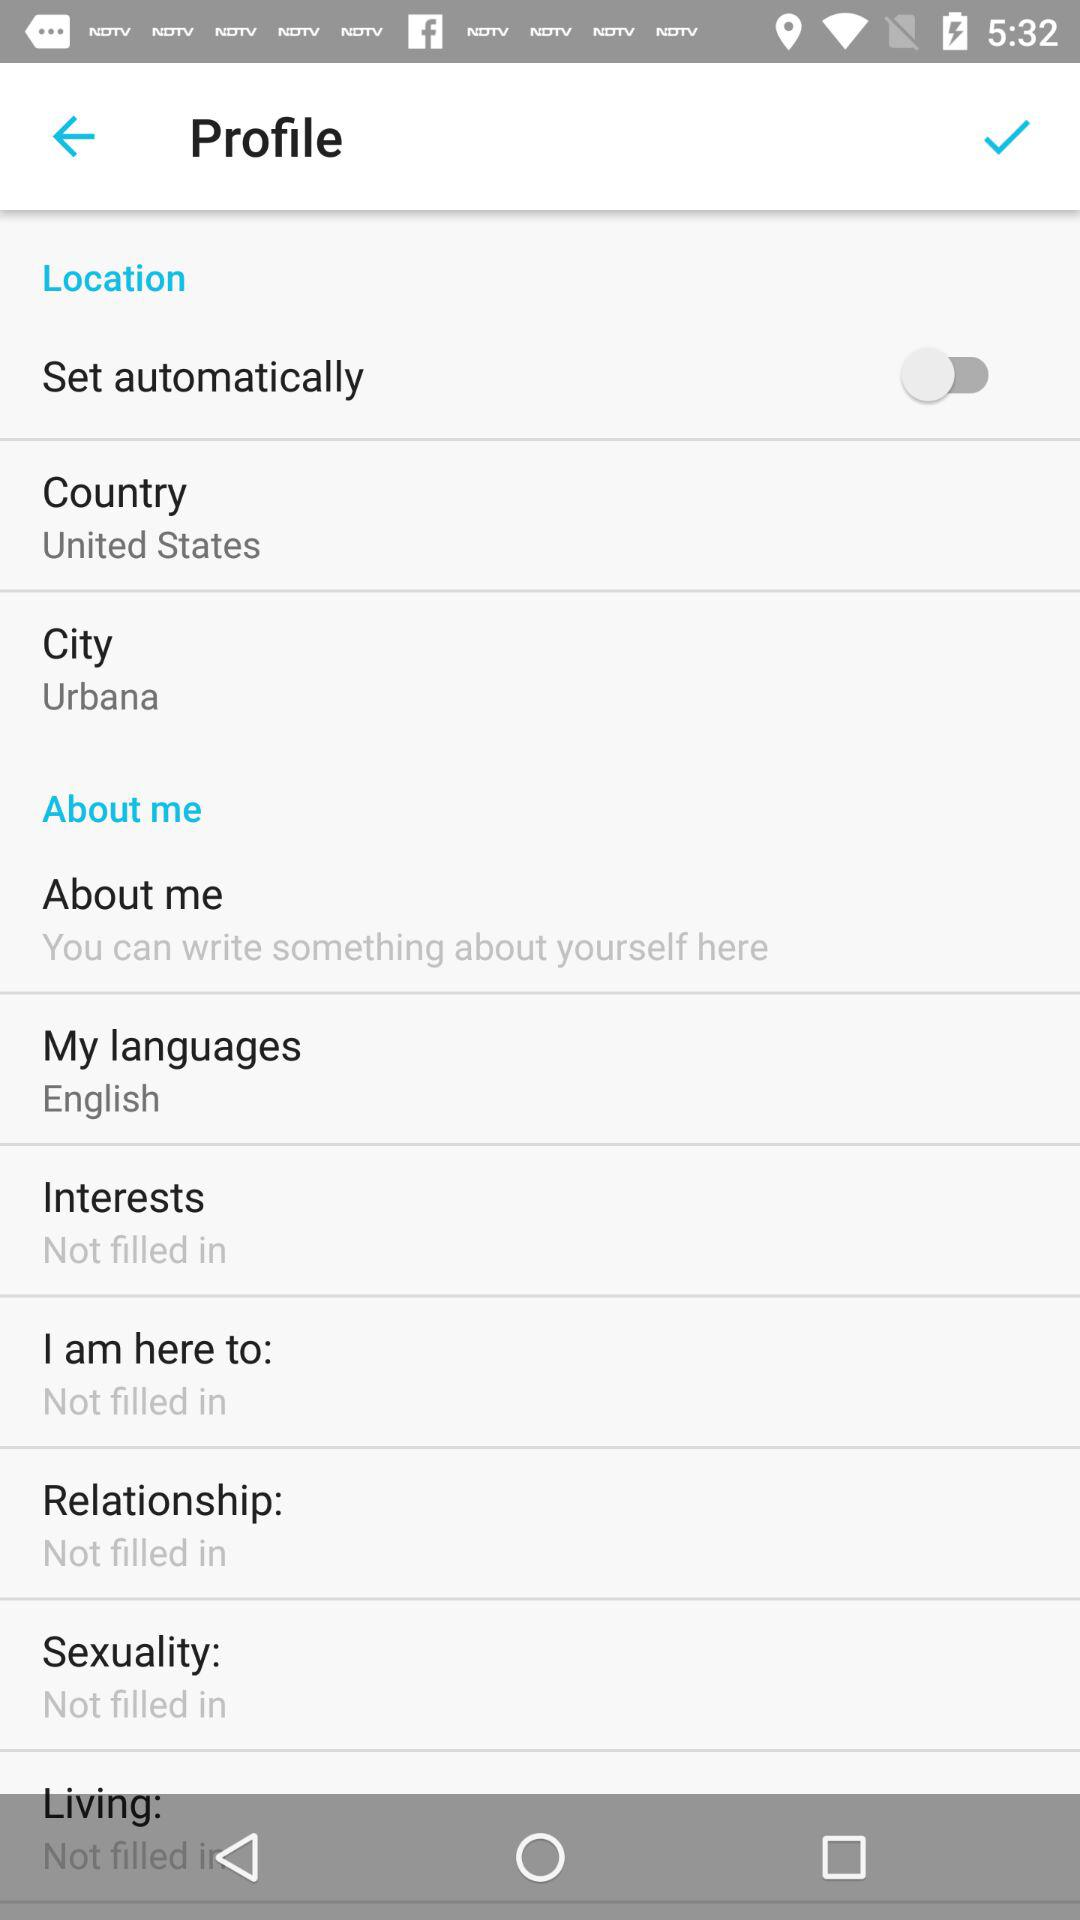What city is given? The given city is Urbana. 